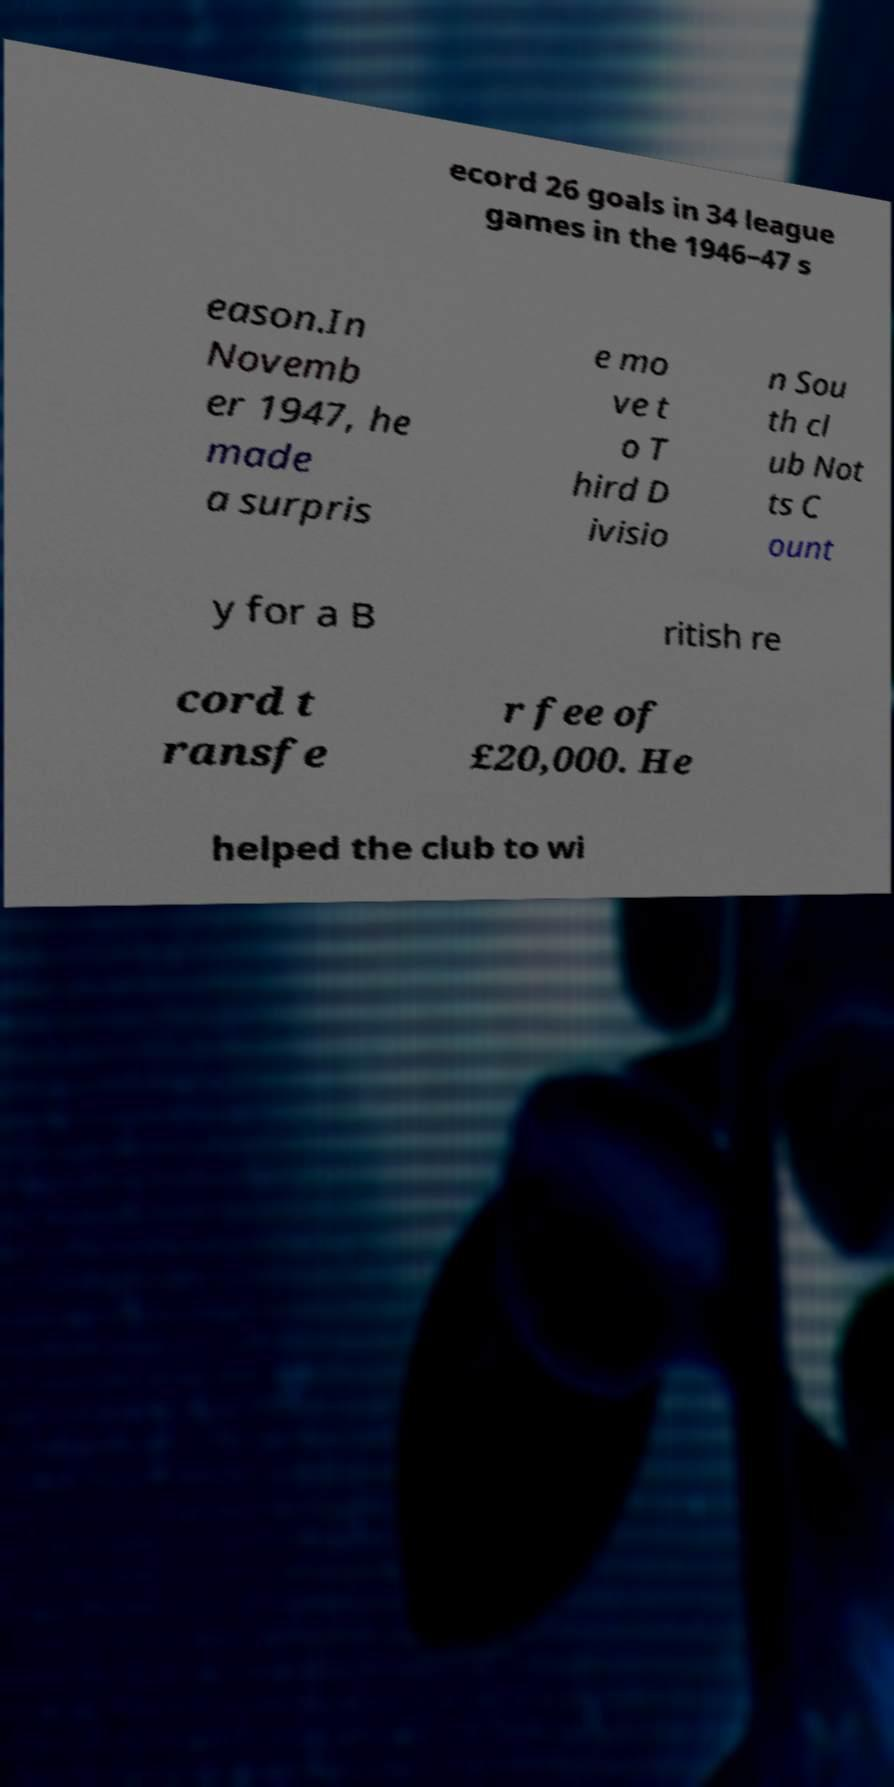For documentation purposes, I need the text within this image transcribed. Could you provide that? ecord 26 goals in 34 league games in the 1946–47 s eason.In Novemb er 1947, he made a surpris e mo ve t o T hird D ivisio n Sou th cl ub Not ts C ount y for a B ritish re cord t ransfe r fee of £20,000. He helped the club to wi 